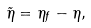<formula> <loc_0><loc_0><loc_500><loc_500>\tilde { \eta } = \eta _ { f } - \eta ,</formula> 